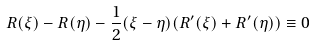<formula> <loc_0><loc_0><loc_500><loc_500>R ( \xi ) - R ( \eta ) - \frac { 1 } { 2 } ( \xi - \eta ) ( R ^ { \prime } ( \xi ) + R ^ { \prime } ( \eta ) ) \equiv 0</formula> 